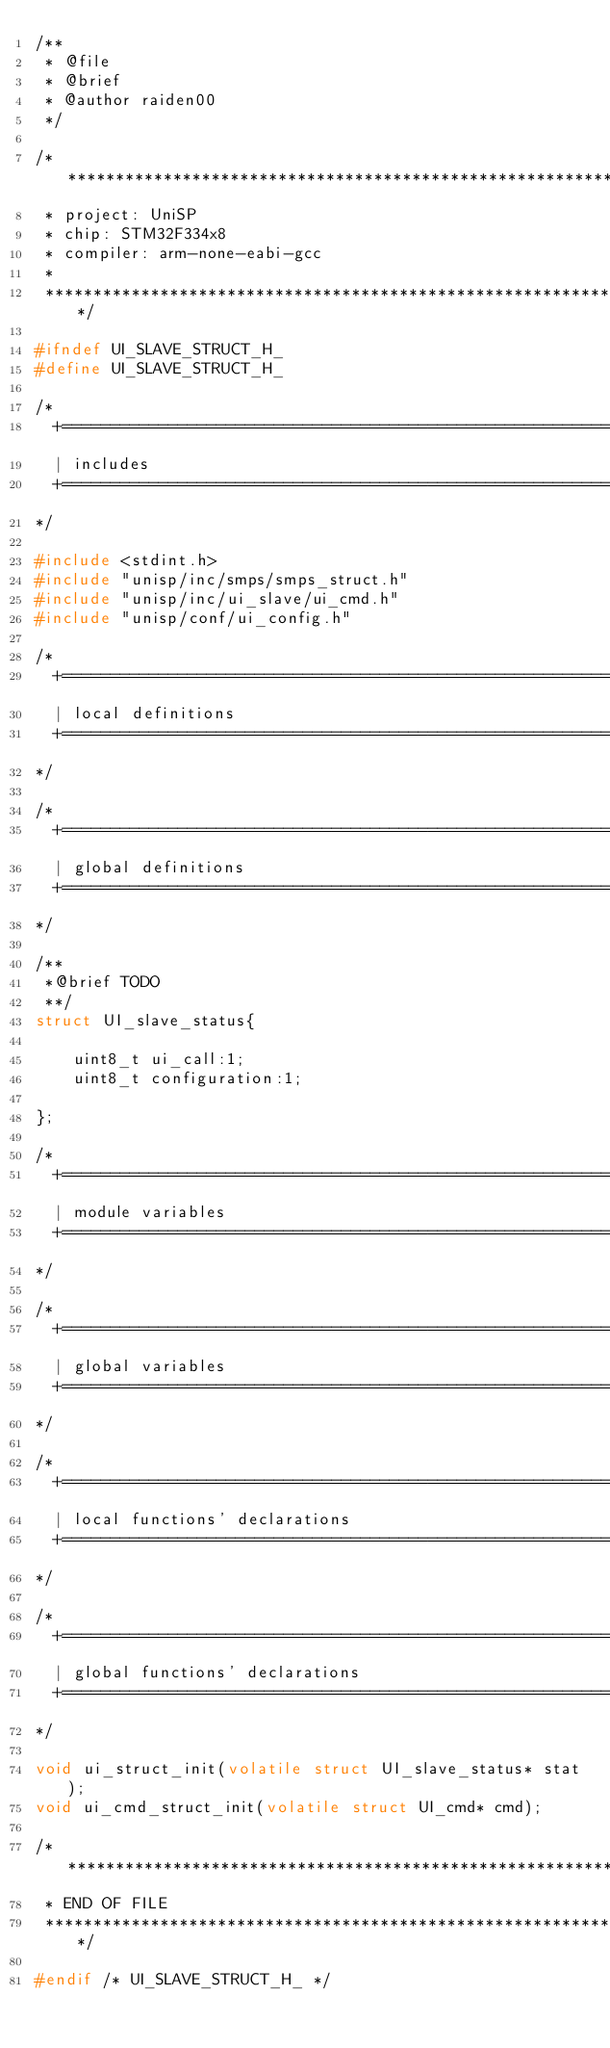<code> <loc_0><loc_0><loc_500><loc_500><_C_>/**
 * @file
 * @brief
 * @author raiden00
 */

/******************************************************************************
 * project: UniSP
 * chip: STM32F334x8
 * compiler: arm-none-eabi-gcc
 *
 ******************************************************************************/

#ifndef UI_SLAVE_STRUCT_H_
#define UI_SLAVE_STRUCT_H_

/*
  +=============================================================================+
  | includes
  +=============================================================================+
*/

#include <stdint.h>
#include "unisp/inc/smps/smps_struct.h"
#include "unisp/inc/ui_slave/ui_cmd.h"
#include "unisp/conf/ui_config.h"

/*
  +=============================================================================+
  | local definitions
  +=============================================================================+
*/

/*
  +=============================================================================+
  | global definitions
  +=============================================================================+
*/

/**
 *@brief TODO
 **/
struct UI_slave_status{

    uint8_t ui_call:1;
    uint8_t configuration:1;

};

/*
  +=============================================================================+
  | module variables
  +=============================================================================+
*/

/*
  +=============================================================================+
  | global variables
  +=============================================================================+
*/

/*
  +=============================================================================+
  | local functions' declarations
  +=============================================================================+
*/

/*
  +=============================================================================+
  | global functions' declarations
  +=============================================================================+
*/

void ui_struct_init(volatile struct UI_slave_status* stat);
void ui_cmd_struct_init(volatile struct UI_cmd* cmd);

/******************************************************************************
 * END OF FILE
 ******************************************************************************/

#endif /* UI_SLAVE_STRUCT_H_ */
</code> 